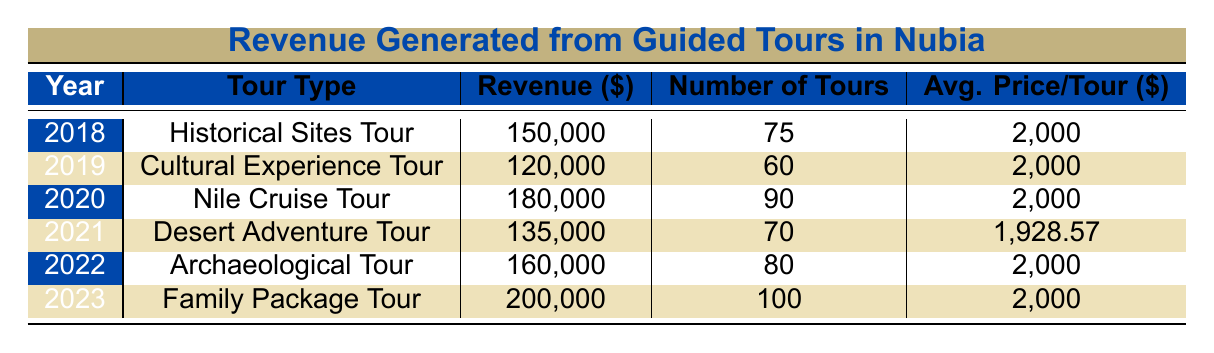What was the highest revenue generated from guided tours in Nubia? The table shows the revenue for each year. In 2023, the revenue was 200,000, which is higher than all the previous years listed (150,000 in 2018, 120,000 in 2019, 180,000 in 2020, 135,000 in 2021, and 160,000 in 2022). Thus, the highest revenue is 200,000.
Answer: 200000 In which year was the lowest number of tours conducted? The table lists the number of tours for each year. The lowest number of tours occurred in 2019, with only 60 tours compared to other years where the counts were higher (75 in 2018, 90 in 2020, 70 in 2021, 80 in 2022, and 100 in 2023).
Answer: 2019 What was the average revenue generated from tours in 2020 and 2021 combined? The revenue for 2020 is 180,000 and for 2021 is 135,000. Adding these amounts gives us 180,000 + 135,000 = 315,000. There are two years, so we divide by 2 to find the average: 315,000 / 2 = 157,500.
Answer: 157500 Did the average price per tour increase from 2021 to 2022? In 2021, the average price per tour was 1,928.57 dollars, while in 2022 it was 2,000 dollars. Since 2,000 is greater than 1,928.57, this indicates that the average price per tour did increase.
Answer: Yes How much revenue was generated from all tours in 2018, 2019, and 2020 combined? The revenue for 2018 is 150,000, for 2019 it is 120,000, and for 2020 it is 180,000. Adding them gives: 150,000 + 120,000 + 180,000 = 450,000.
Answer: 450000 What is the difference in revenue between the tours in 2023 and 2021? The revenue for 2023 is 200,000 and for 2021 it is 135,000. To find the difference, we subtract 135,000 from 200,000: 200,000 - 135,000 = 65,000.
Answer: 65000 Was the number of tours in 2022 higher than in 2020? In 2022, there were 80 tours, and in 2020, there were 90 tours. Since 80 is less than 90, the number of tours in 2022 was not higher than in 2020.
Answer: No What was the average number of tours conducted from 2018 to 2022? Adding the number of tours: 75 (2018) + 60 (2019) + 90 (2020) + 70 (2021) + 80 (2022) = 375. There are 5 years, so the average is 375 / 5 = 75.
Answer: 75 